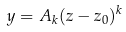Convert formula to latex. <formula><loc_0><loc_0><loc_500><loc_500>y = A _ { k } ( z - z _ { 0 } ) ^ { k }</formula> 